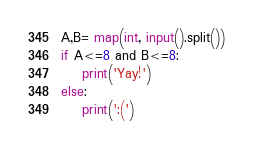Convert code to text. <code><loc_0><loc_0><loc_500><loc_500><_Python_>A,B= map(int, input().split())
if A<=8 and B<=8:
    print('Yay!')
else:
    print(':(')</code> 